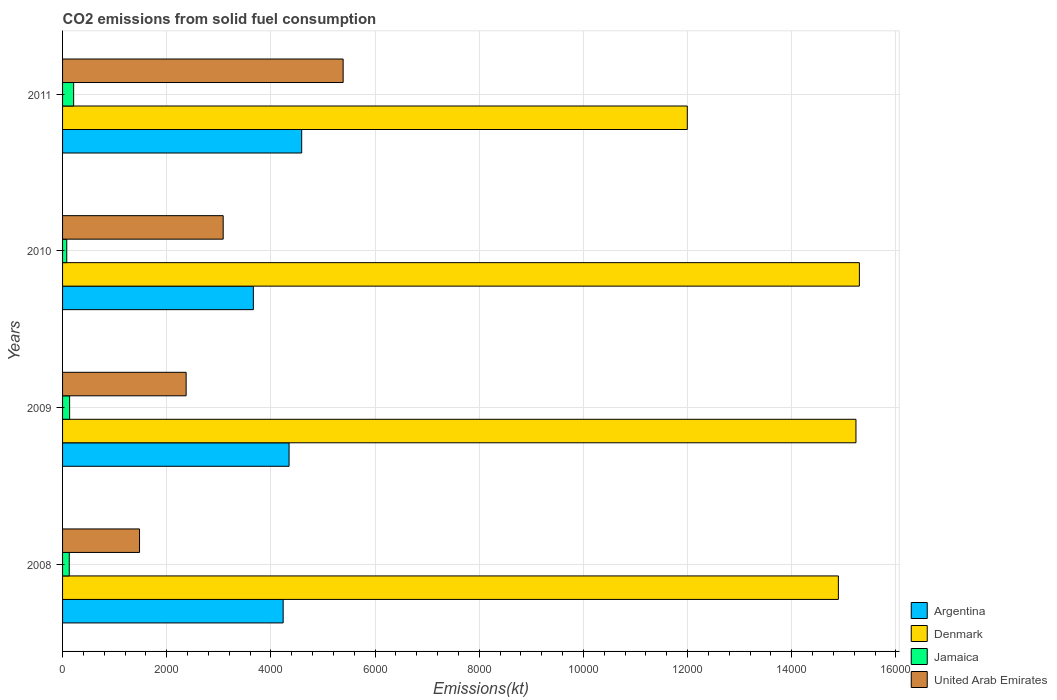How many bars are there on the 1st tick from the bottom?
Your response must be concise. 4. What is the label of the 4th group of bars from the top?
Provide a short and direct response. 2008. What is the amount of CO2 emitted in Denmark in 2011?
Ensure brevity in your answer.  1.20e+04. Across all years, what is the maximum amount of CO2 emitted in Argentina?
Keep it short and to the point. 4591.08. Across all years, what is the minimum amount of CO2 emitted in Denmark?
Your response must be concise. 1.20e+04. What is the total amount of CO2 emitted in United Arab Emirates in the graph?
Provide a succinct answer. 1.23e+04. What is the difference between the amount of CO2 emitted in Jamaica in 2009 and that in 2010?
Ensure brevity in your answer.  55.01. What is the difference between the amount of CO2 emitted in United Arab Emirates in 2009 and the amount of CO2 emitted in Denmark in 2008?
Ensure brevity in your answer.  -1.25e+04. What is the average amount of CO2 emitted in Jamaica per year?
Keep it short and to the point. 139.35. In the year 2011, what is the difference between the amount of CO2 emitted in United Arab Emirates and amount of CO2 emitted in Argentina?
Keep it short and to the point. 795.74. What is the ratio of the amount of CO2 emitted in Argentina in 2009 to that in 2010?
Offer a very short reply. 1.19. Is the difference between the amount of CO2 emitted in United Arab Emirates in 2009 and 2011 greater than the difference between the amount of CO2 emitted in Argentina in 2009 and 2011?
Keep it short and to the point. No. What is the difference between the highest and the second highest amount of CO2 emitted in Denmark?
Make the answer very short. 66.01. What is the difference between the highest and the lowest amount of CO2 emitted in United Arab Emirates?
Keep it short and to the point. 3909.02. Is it the case that in every year, the sum of the amount of CO2 emitted in Denmark and amount of CO2 emitted in Jamaica is greater than the sum of amount of CO2 emitted in United Arab Emirates and amount of CO2 emitted in Argentina?
Your answer should be compact. Yes. What does the 1st bar from the top in 2008 represents?
Provide a short and direct response. United Arab Emirates. How many bars are there?
Offer a terse response. 16. Are all the bars in the graph horizontal?
Give a very brief answer. Yes. How many years are there in the graph?
Offer a very short reply. 4. Are the values on the major ticks of X-axis written in scientific E-notation?
Your answer should be compact. No. Does the graph contain any zero values?
Your answer should be very brief. No. Does the graph contain grids?
Offer a very short reply. Yes. Where does the legend appear in the graph?
Your response must be concise. Bottom right. What is the title of the graph?
Keep it short and to the point. CO2 emissions from solid fuel consumption. Does "Sint Maarten (Dutch part)" appear as one of the legend labels in the graph?
Provide a short and direct response. No. What is the label or title of the X-axis?
Your answer should be very brief. Emissions(kt). What is the Emissions(kt) in Argentina in 2008?
Keep it short and to the point. 4235.39. What is the Emissions(kt) in Denmark in 2008?
Keep it short and to the point. 1.49e+04. What is the Emissions(kt) of Jamaica in 2008?
Provide a succinct answer. 128.34. What is the Emissions(kt) in United Arab Emirates in 2008?
Provide a short and direct response. 1477.8. What is the Emissions(kt) of Argentina in 2009?
Offer a terse response. 4349.06. What is the Emissions(kt) of Denmark in 2009?
Offer a terse response. 1.52e+04. What is the Emissions(kt) of Jamaica in 2009?
Provide a succinct answer. 135.68. What is the Emissions(kt) in United Arab Emirates in 2009?
Keep it short and to the point. 2372.55. What is the Emissions(kt) of Argentina in 2010?
Offer a very short reply. 3663.33. What is the Emissions(kt) of Denmark in 2010?
Give a very brief answer. 1.53e+04. What is the Emissions(kt) in Jamaica in 2010?
Ensure brevity in your answer.  80.67. What is the Emissions(kt) of United Arab Emirates in 2010?
Offer a very short reply. 3083.95. What is the Emissions(kt) of Argentina in 2011?
Your response must be concise. 4591.08. What is the Emissions(kt) of Denmark in 2011?
Your answer should be compact. 1.20e+04. What is the Emissions(kt) in Jamaica in 2011?
Offer a terse response. 212.69. What is the Emissions(kt) of United Arab Emirates in 2011?
Keep it short and to the point. 5386.82. Across all years, what is the maximum Emissions(kt) in Argentina?
Offer a very short reply. 4591.08. Across all years, what is the maximum Emissions(kt) in Denmark?
Ensure brevity in your answer.  1.53e+04. Across all years, what is the maximum Emissions(kt) of Jamaica?
Give a very brief answer. 212.69. Across all years, what is the maximum Emissions(kt) of United Arab Emirates?
Keep it short and to the point. 5386.82. Across all years, what is the minimum Emissions(kt) in Argentina?
Your answer should be very brief. 3663.33. Across all years, what is the minimum Emissions(kt) of Denmark?
Ensure brevity in your answer.  1.20e+04. Across all years, what is the minimum Emissions(kt) of Jamaica?
Make the answer very short. 80.67. Across all years, what is the minimum Emissions(kt) of United Arab Emirates?
Your answer should be compact. 1477.8. What is the total Emissions(kt) of Argentina in the graph?
Your answer should be compact. 1.68e+04. What is the total Emissions(kt) in Denmark in the graph?
Make the answer very short. 5.74e+04. What is the total Emissions(kt) of Jamaica in the graph?
Provide a short and direct response. 557.38. What is the total Emissions(kt) in United Arab Emirates in the graph?
Offer a terse response. 1.23e+04. What is the difference between the Emissions(kt) of Argentina in 2008 and that in 2009?
Make the answer very short. -113.68. What is the difference between the Emissions(kt) of Denmark in 2008 and that in 2009?
Offer a terse response. -337.36. What is the difference between the Emissions(kt) in Jamaica in 2008 and that in 2009?
Provide a short and direct response. -7.33. What is the difference between the Emissions(kt) in United Arab Emirates in 2008 and that in 2009?
Your answer should be very brief. -894.75. What is the difference between the Emissions(kt) of Argentina in 2008 and that in 2010?
Your answer should be compact. 572.05. What is the difference between the Emissions(kt) in Denmark in 2008 and that in 2010?
Provide a succinct answer. -403.37. What is the difference between the Emissions(kt) of Jamaica in 2008 and that in 2010?
Offer a very short reply. 47.67. What is the difference between the Emissions(kt) of United Arab Emirates in 2008 and that in 2010?
Give a very brief answer. -1606.15. What is the difference between the Emissions(kt) of Argentina in 2008 and that in 2011?
Your answer should be compact. -355.7. What is the difference between the Emissions(kt) in Denmark in 2008 and that in 2011?
Give a very brief answer. 2900.6. What is the difference between the Emissions(kt) in Jamaica in 2008 and that in 2011?
Provide a succinct answer. -84.34. What is the difference between the Emissions(kt) of United Arab Emirates in 2008 and that in 2011?
Your answer should be very brief. -3909.02. What is the difference between the Emissions(kt) of Argentina in 2009 and that in 2010?
Your answer should be very brief. 685.73. What is the difference between the Emissions(kt) of Denmark in 2009 and that in 2010?
Provide a short and direct response. -66.01. What is the difference between the Emissions(kt) of Jamaica in 2009 and that in 2010?
Keep it short and to the point. 55.01. What is the difference between the Emissions(kt) in United Arab Emirates in 2009 and that in 2010?
Offer a very short reply. -711.4. What is the difference between the Emissions(kt) in Argentina in 2009 and that in 2011?
Provide a short and direct response. -242.02. What is the difference between the Emissions(kt) in Denmark in 2009 and that in 2011?
Your response must be concise. 3237.96. What is the difference between the Emissions(kt) of Jamaica in 2009 and that in 2011?
Provide a succinct answer. -77.01. What is the difference between the Emissions(kt) of United Arab Emirates in 2009 and that in 2011?
Provide a short and direct response. -3014.27. What is the difference between the Emissions(kt) in Argentina in 2010 and that in 2011?
Ensure brevity in your answer.  -927.75. What is the difference between the Emissions(kt) in Denmark in 2010 and that in 2011?
Make the answer very short. 3303.97. What is the difference between the Emissions(kt) in Jamaica in 2010 and that in 2011?
Provide a succinct answer. -132.01. What is the difference between the Emissions(kt) in United Arab Emirates in 2010 and that in 2011?
Your response must be concise. -2302.88. What is the difference between the Emissions(kt) in Argentina in 2008 and the Emissions(kt) in Denmark in 2009?
Offer a terse response. -1.10e+04. What is the difference between the Emissions(kt) of Argentina in 2008 and the Emissions(kt) of Jamaica in 2009?
Make the answer very short. 4099.71. What is the difference between the Emissions(kt) in Argentina in 2008 and the Emissions(kt) in United Arab Emirates in 2009?
Offer a terse response. 1862.84. What is the difference between the Emissions(kt) of Denmark in 2008 and the Emissions(kt) of Jamaica in 2009?
Your response must be concise. 1.48e+04. What is the difference between the Emissions(kt) of Denmark in 2008 and the Emissions(kt) of United Arab Emirates in 2009?
Your answer should be very brief. 1.25e+04. What is the difference between the Emissions(kt) of Jamaica in 2008 and the Emissions(kt) of United Arab Emirates in 2009?
Keep it short and to the point. -2244.2. What is the difference between the Emissions(kt) in Argentina in 2008 and the Emissions(kt) in Denmark in 2010?
Your answer should be very brief. -1.11e+04. What is the difference between the Emissions(kt) in Argentina in 2008 and the Emissions(kt) in Jamaica in 2010?
Ensure brevity in your answer.  4154.71. What is the difference between the Emissions(kt) in Argentina in 2008 and the Emissions(kt) in United Arab Emirates in 2010?
Offer a very short reply. 1151.44. What is the difference between the Emissions(kt) of Denmark in 2008 and the Emissions(kt) of Jamaica in 2010?
Your answer should be compact. 1.48e+04. What is the difference between the Emissions(kt) of Denmark in 2008 and the Emissions(kt) of United Arab Emirates in 2010?
Ensure brevity in your answer.  1.18e+04. What is the difference between the Emissions(kt) in Jamaica in 2008 and the Emissions(kt) in United Arab Emirates in 2010?
Your answer should be very brief. -2955.6. What is the difference between the Emissions(kt) of Argentina in 2008 and the Emissions(kt) of Denmark in 2011?
Provide a succinct answer. -7759.37. What is the difference between the Emissions(kt) of Argentina in 2008 and the Emissions(kt) of Jamaica in 2011?
Offer a very short reply. 4022.7. What is the difference between the Emissions(kt) in Argentina in 2008 and the Emissions(kt) in United Arab Emirates in 2011?
Ensure brevity in your answer.  -1151.44. What is the difference between the Emissions(kt) in Denmark in 2008 and the Emissions(kt) in Jamaica in 2011?
Your answer should be very brief. 1.47e+04. What is the difference between the Emissions(kt) in Denmark in 2008 and the Emissions(kt) in United Arab Emirates in 2011?
Your answer should be very brief. 9508.53. What is the difference between the Emissions(kt) of Jamaica in 2008 and the Emissions(kt) of United Arab Emirates in 2011?
Your response must be concise. -5258.48. What is the difference between the Emissions(kt) in Argentina in 2009 and the Emissions(kt) in Denmark in 2010?
Offer a terse response. -1.09e+04. What is the difference between the Emissions(kt) of Argentina in 2009 and the Emissions(kt) of Jamaica in 2010?
Your answer should be compact. 4268.39. What is the difference between the Emissions(kt) of Argentina in 2009 and the Emissions(kt) of United Arab Emirates in 2010?
Your answer should be compact. 1265.12. What is the difference between the Emissions(kt) in Denmark in 2009 and the Emissions(kt) in Jamaica in 2010?
Your answer should be very brief. 1.52e+04. What is the difference between the Emissions(kt) in Denmark in 2009 and the Emissions(kt) in United Arab Emirates in 2010?
Your response must be concise. 1.21e+04. What is the difference between the Emissions(kt) of Jamaica in 2009 and the Emissions(kt) of United Arab Emirates in 2010?
Make the answer very short. -2948.27. What is the difference between the Emissions(kt) in Argentina in 2009 and the Emissions(kt) in Denmark in 2011?
Offer a very short reply. -7645.69. What is the difference between the Emissions(kt) in Argentina in 2009 and the Emissions(kt) in Jamaica in 2011?
Provide a short and direct response. 4136.38. What is the difference between the Emissions(kt) in Argentina in 2009 and the Emissions(kt) in United Arab Emirates in 2011?
Your answer should be compact. -1037.76. What is the difference between the Emissions(kt) in Denmark in 2009 and the Emissions(kt) in Jamaica in 2011?
Ensure brevity in your answer.  1.50e+04. What is the difference between the Emissions(kt) of Denmark in 2009 and the Emissions(kt) of United Arab Emirates in 2011?
Keep it short and to the point. 9845.9. What is the difference between the Emissions(kt) in Jamaica in 2009 and the Emissions(kt) in United Arab Emirates in 2011?
Ensure brevity in your answer.  -5251.14. What is the difference between the Emissions(kt) in Argentina in 2010 and the Emissions(kt) in Denmark in 2011?
Offer a terse response. -8331.42. What is the difference between the Emissions(kt) in Argentina in 2010 and the Emissions(kt) in Jamaica in 2011?
Your answer should be very brief. 3450.65. What is the difference between the Emissions(kt) of Argentina in 2010 and the Emissions(kt) of United Arab Emirates in 2011?
Offer a terse response. -1723.49. What is the difference between the Emissions(kt) of Denmark in 2010 and the Emissions(kt) of Jamaica in 2011?
Provide a short and direct response. 1.51e+04. What is the difference between the Emissions(kt) of Denmark in 2010 and the Emissions(kt) of United Arab Emirates in 2011?
Provide a short and direct response. 9911.9. What is the difference between the Emissions(kt) in Jamaica in 2010 and the Emissions(kt) in United Arab Emirates in 2011?
Provide a short and direct response. -5306.15. What is the average Emissions(kt) of Argentina per year?
Provide a short and direct response. 4209.72. What is the average Emissions(kt) of Denmark per year?
Make the answer very short. 1.44e+04. What is the average Emissions(kt) of Jamaica per year?
Ensure brevity in your answer.  139.35. What is the average Emissions(kt) in United Arab Emirates per year?
Provide a succinct answer. 3080.28. In the year 2008, what is the difference between the Emissions(kt) of Argentina and Emissions(kt) of Denmark?
Provide a succinct answer. -1.07e+04. In the year 2008, what is the difference between the Emissions(kt) in Argentina and Emissions(kt) in Jamaica?
Keep it short and to the point. 4107.04. In the year 2008, what is the difference between the Emissions(kt) in Argentina and Emissions(kt) in United Arab Emirates?
Offer a terse response. 2757.58. In the year 2008, what is the difference between the Emissions(kt) of Denmark and Emissions(kt) of Jamaica?
Give a very brief answer. 1.48e+04. In the year 2008, what is the difference between the Emissions(kt) in Denmark and Emissions(kt) in United Arab Emirates?
Provide a short and direct response. 1.34e+04. In the year 2008, what is the difference between the Emissions(kt) of Jamaica and Emissions(kt) of United Arab Emirates?
Provide a short and direct response. -1349.46. In the year 2009, what is the difference between the Emissions(kt) in Argentina and Emissions(kt) in Denmark?
Make the answer very short. -1.09e+04. In the year 2009, what is the difference between the Emissions(kt) in Argentina and Emissions(kt) in Jamaica?
Ensure brevity in your answer.  4213.38. In the year 2009, what is the difference between the Emissions(kt) of Argentina and Emissions(kt) of United Arab Emirates?
Give a very brief answer. 1976.51. In the year 2009, what is the difference between the Emissions(kt) of Denmark and Emissions(kt) of Jamaica?
Give a very brief answer. 1.51e+04. In the year 2009, what is the difference between the Emissions(kt) of Denmark and Emissions(kt) of United Arab Emirates?
Your answer should be compact. 1.29e+04. In the year 2009, what is the difference between the Emissions(kt) in Jamaica and Emissions(kt) in United Arab Emirates?
Your answer should be compact. -2236.87. In the year 2010, what is the difference between the Emissions(kt) of Argentina and Emissions(kt) of Denmark?
Provide a succinct answer. -1.16e+04. In the year 2010, what is the difference between the Emissions(kt) in Argentina and Emissions(kt) in Jamaica?
Your response must be concise. 3582.66. In the year 2010, what is the difference between the Emissions(kt) in Argentina and Emissions(kt) in United Arab Emirates?
Your answer should be very brief. 579.39. In the year 2010, what is the difference between the Emissions(kt) of Denmark and Emissions(kt) of Jamaica?
Offer a very short reply. 1.52e+04. In the year 2010, what is the difference between the Emissions(kt) in Denmark and Emissions(kt) in United Arab Emirates?
Your answer should be compact. 1.22e+04. In the year 2010, what is the difference between the Emissions(kt) of Jamaica and Emissions(kt) of United Arab Emirates?
Give a very brief answer. -3003.27. In the year 2011, what is the difference between the Emissions(kt) in Argentina and Emissions(kt) in Denmark?
Offer a terse response. -7403.67. In the year 2011, what is the difference between the Emissions(kt) in Argentina and Emissions(kt) in Jamaica?
Give a very brief answer. 4378.4. In the year 2011, what is the difference between the Emissions(kt) in Argentina and Emissions(kt) in United Arab Emirates?
Offer a terse response. -795.74. In the year 2011, what is the difference between the Emissions(kt) in Denmark and Emissions(kt) in Jamaica?
Keep it short and to the point. 1.18e+04. In the year 2011, what is the difference between the Emissions(kt) in Denmark and Emissions(kt) in United Arab Emirates?
Offer a very short reply. 6607.93. In the year 2011, what is the difference between the Emissions(kt) of Jamaica and Emissions(kt) of United Arab Emirates?
Your response must be concise. -5174.14. What is the ratio of the Emissions(kt) in Argentina in 2008 to that in 2009?
Offer a terse response. 0.97. What is the ratio of the Emissions(kt) in Denmark in 2008 to that in 2009?
Your answer should be compact. 0.98. What is the ratio of the Emissions(kt) of Jamaica in 2008 to that in 2009?
Ensure brevity in your answer.  0.95. What is the ratio of the Emissions(kt) of United Arab Emirates in 2008 to that in 2009?
Keep it short and to the point. 0.62. What is the ratio of the Emissions(kt) of Argentina in 2008 to that in 2010?
Keep it short and to the point. 1.16. What is the ratio of the Emissions(kt) of Denmark in 2008 to that in 2010?
Keep it short and to the point. 0.97. What is the ratio of the Emissions(kt) in Jamaica in 2008 to that in 2010?
Your answer should be compact. 1.59. What is the ratio of the Emissions(kt) in United Arab Emirates in 2008 to that in 2010?
Provide a short and direct response. 0.48. What is the ratio of the Emissions(kt) of Argentina in 2008 to that in 2011?
Make the answer very short. 0.92. What is the ratio of the Emissions(kt) in Denmark in 2008 to that in 2011?
Provide a short and direct response. 1.24. What is the ratio of the Emissions(kt) of Jamaica in 2008 to that in 2011?
Your answer should be compact. 0.6. What is the ratio of the Emissions(kt) of United Arab Emirates in 2008 to that in 2011?
Offer a terse response. 0.27. What is the ratio of the Emissions(kt) in Argentina in 2009 to that in 2010?
Offer a terse response. 1.19. What is the ratio of the Emissions(kt) of Jamaica in 2009 to that in 2010?
Offer a very short reply. 1.68. What is the ratio of the Emissions(kt) in United Arab Emirates in 2009 to that in 2010?
Ensure brevity in your answer.  0.77. What is the ratio of the Emissions(kt) in Argentina in 2009 to that in 2011?
Keep it short and to the point. 0.95. What is the ratio of the Emissions(kt) in Denmark in 2009 to that in 2011?
Offer a terse response. 1.27. What is the ratio of the Emissions(kt) of Jamaica in 2009 to that in 2011?
Keep it short and to the point. 0.64. What is the ratio of the Emissions(kt) of United Arab Emirates in 2009 to that in 2011?
Provide a short and direct response. 0.44. What is the ratio of the Emissions(kt) in Argentina in 2010 to that in 2011?
Provide a succinct answer. 0.8. What is the ratio of the Emissions(kt) in Denmark in 2010 to that in 2011?
Offer a very short reply. 1.28. What is the ratio of the Emissions(kt) of Jamaica in 2010 to that in 2011?
Your answer should be very brief. 0.38. What is the ratio of the Emissions(kt) in United Arab Emirates in 2010 to that in 2011?
Provide a succinct answer. 0.57. What is the difference between the highest and the second highest Emissions(kt) in Argentina?
Ensure brevity in your answer.  242.02. What is the difference between the highest and the second highest Emissions(kt) of Denmark?
Offer a terse response. 66.01. What is the difference between the highest and the second highest Emissions(kt) of Jamaica?
Make the answer very short. 77.01. What is the difference between the highest and the second highest Emissions(kt) of United Arab Emirates?
Your answer should be compact. 2302.88. What is the difference between the highest and the lowest Emissions(kt) in Argentina?
Offer a very short reply. 927.75. What is the difference between the highest and the lowest Emissions(kt) in Denmark?
Provide a short and direct response. 3303.97. What is the difference between the highest and the lowest Emissions(kt) of Jamaica?
Your answer should be compact. 132.01. What is the difference between the highest and the lowest Emissions(kt) in United Arab Emirates?
Ensure brevity in your answer.  3909.02. 